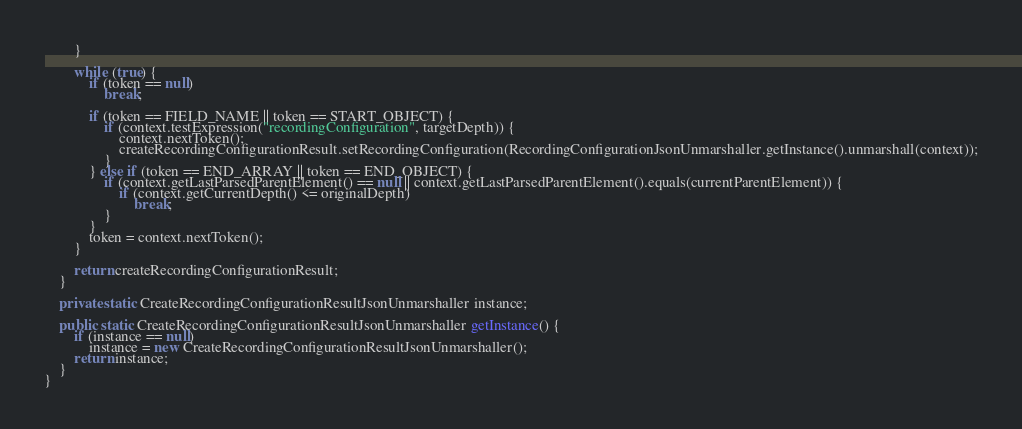<code> <loc_0><loc_0><loc_500><loc_500><_Java_>        }

        while (true) {
            if (token == null)
                break;

            if (token == FIELD_NAME || token == START_OBJECT) {
                if (context.testExpression("recordingConfiguration", targetDepth)) {
                    context.nextToken();
                    createRecordingConfigurationResult.setRecordingConfiguration(RecordingConfigurationJsonUnmarshaller.getInstance().unmarshall(context));
                }
            } else if (token == END_ARRAY || token == END_OBJECT) {
                if (context.getLastParsedParentElement() == null || context.getLastParsedParentElement().equals(currentParentElement)) {
                    if (context.getCurrentDepth() <= originalDepth)
                        break;
                }
            }
            token = context.nextToken();
        }

        return createRecordingConfigurationResult;
    }

    private static CreateRecordingConfigurationResultJsonUnmarshaller instance;

    public static CreateRecordingConfigurationResultJsonUnmarshaller getInstance() {
        if (instance == null)
            instance = new CreateRecordingConfigurationResultJsonUnmarshaller();
        return instance;
    }
}
</code> 